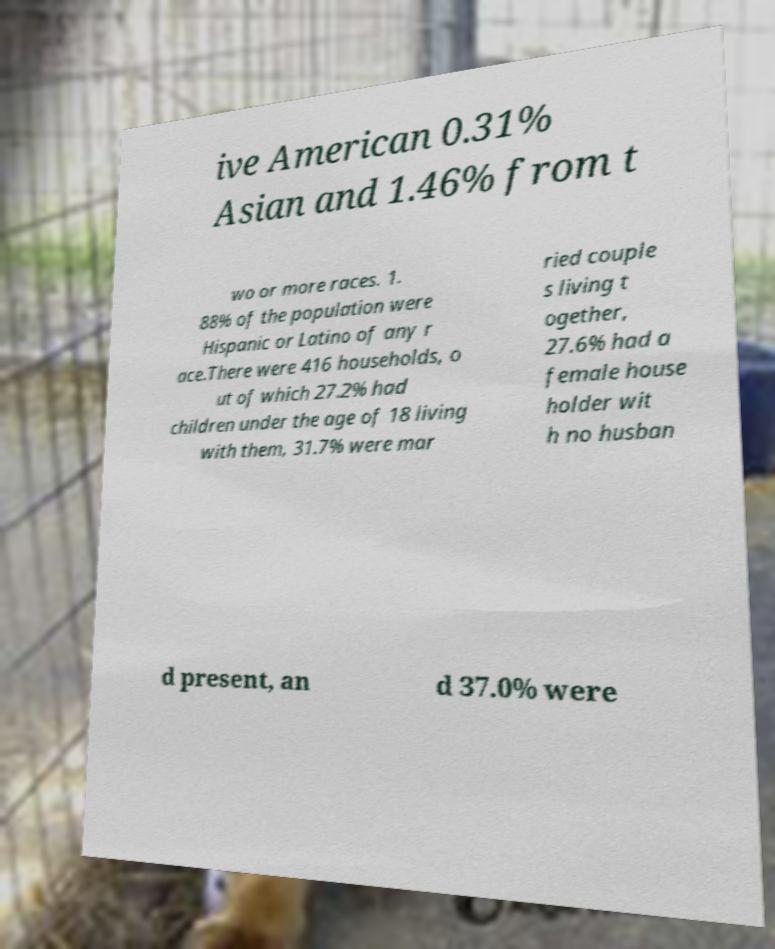Can you accurately transcribe the text from the provided image for me? ive American 0.31% Asian and 1.46% from t wo or more races. 1. 88% of the population were Hispanic or Latino of any r ace.There were 416 households, o ut of which 27.2% had children under the age of 18 living with them, 31.7% were mar ried couple s living t ogether, 27.6% had a female house holder wit h no husban d present, an d 37.0% were 